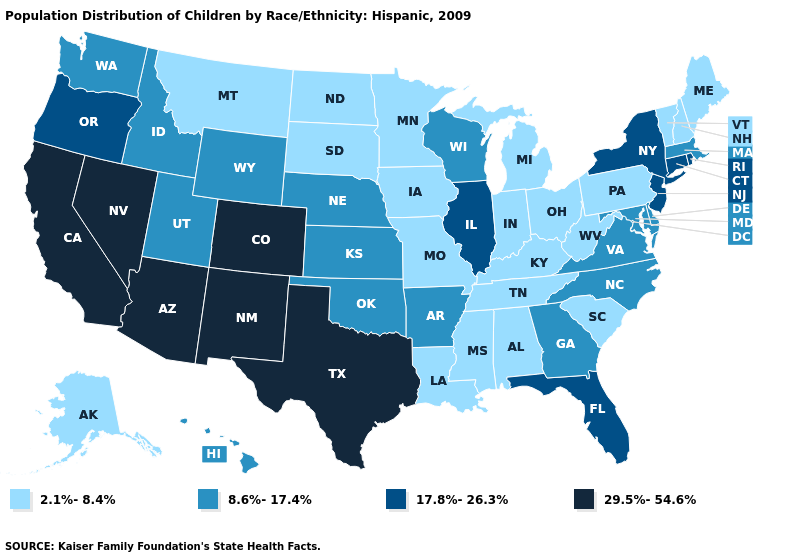Name the states that have a value in the range 29.5%-54.6%?
Answer briefly. Arizona, California, Colorado, Nevada, New Mexico, Texas. How many symbols are there in the legend?
Short answer required. 4. What is the value of North Carolina?
Concise answer only. 8.6%-17.4%. Among the states that border Virginia , which have the highest value?
Keep it brief. Maryland, North Carolina. Name the states that have a value in the range 8.6%-17.4%?
Short answer required. Arkansas, Delaware, Georgia, Hawaii, Idaho, Kansas, Maryland, Massachusetts, Nebraska, North Carolina, Oklahoma, Utah, Virginia, Washington, Wisconsin, Wyoming. Is the legend a continuous bar?
Keep it brief. No. What is the value of New Mexico?
Keep it brief. 29.5%-54.6%. Does the first symbol in the legend represent the smallest category?
Short answer required. Yes. What is the lowest value in states that border Louisiana?
Answer briefly. 2.1%-8.4%. How many symbols are there in the legend?
Keep it brief. 4. Does Texas have the highest value in the South?
Be succinct. Yes. Among the states that border Idaho , which have the highest value?
Concise answer only. Nevada. What is the lowest value in the MidWest?
Write a very short answer. 2.1%-8.4%. Does the map have missing data?
Write a very short answer. No. What is the value of South Carolina?
Keep it brief. 2.1%-8.4%. 